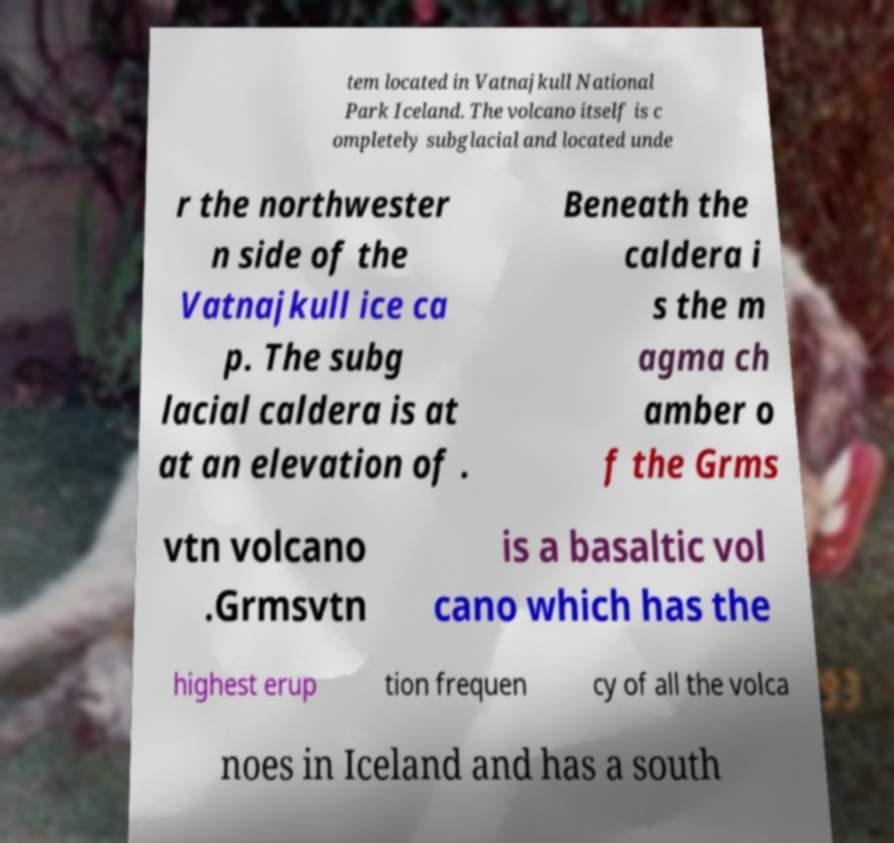Could you extract and type out the text from this image? tem located in Vatnajkull National Park Iceland. The volcano itself is c ompletely subglacial and located unde r the northwester n side of the Vatnajkull ice ca p. The subg lacial caldera is at at an elevation of . Beneath the caldera i s the m agma ch amber o f the Grms vtn volcano .Grmsvtn is a basaltic vol cano which has the highest erup tion frequen cy of all the volca noes in Iceland and has a south 